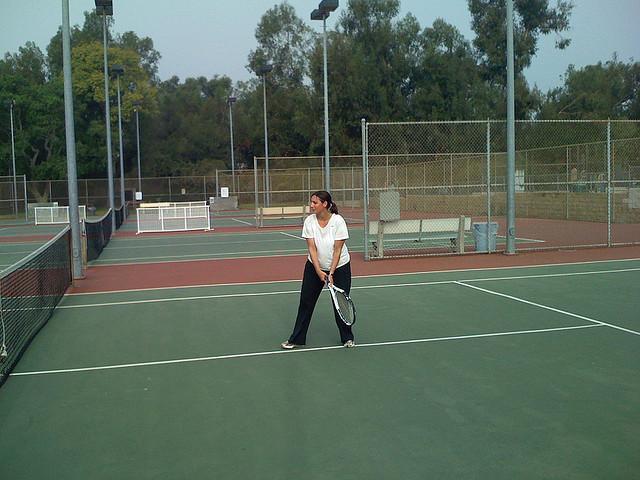How many rackets are there?
Give a very brief answer. 1. 